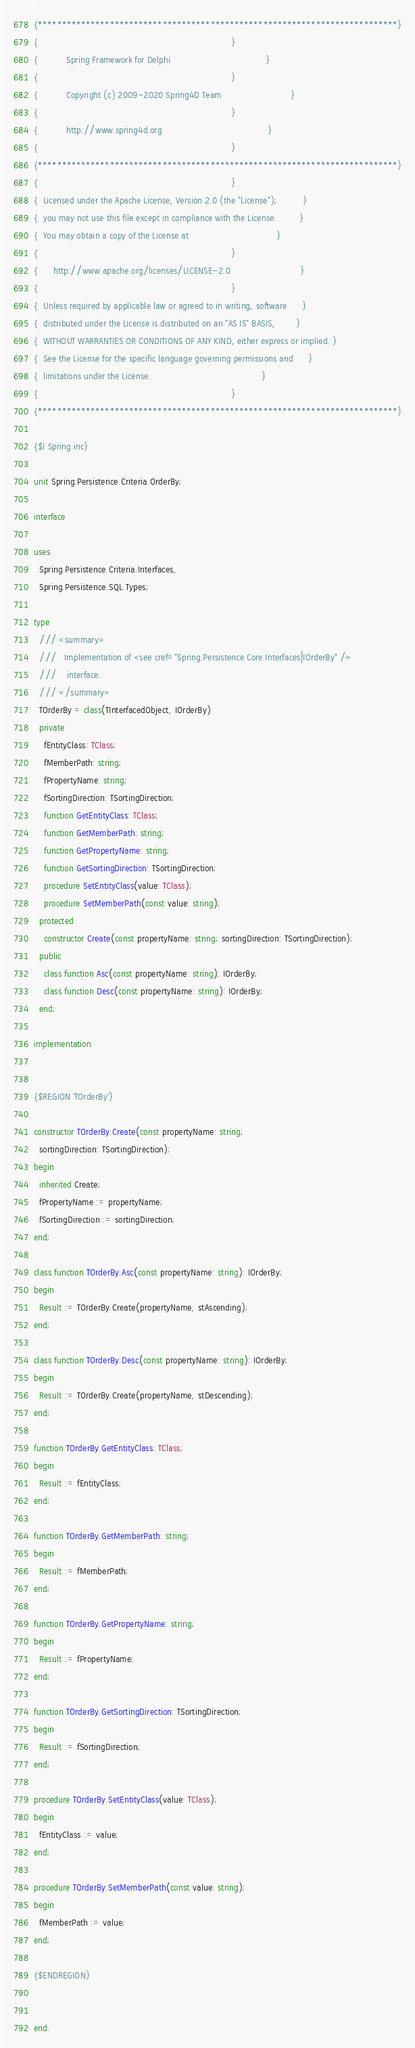Convert code to text. <code><loc_0><loc_0><loc_500><loc_500><_Pascal_>{***************************************************************************}
{                                                                           }
{           Spring Framework for Delphi                                     }
{                                                                           }
{           Copyright (c) 2009-2020 Spring4D Team                           }
{                                                                           }
{           http://www.spring4d.org                                         }
{                                                                           }
{***************************************************************************}
{                                                                           }
{  Licensed under the Apache License, Version 2.0 (the "License");          }
{  you may not use this file except in compliance with the License.         }
{  You may obtain a copy of the License at                                  }
{                                                                           }
{      http://www.apache.org/licenses/LICENSE-2.0                           }
{                                                                           }
{  Unless required by applicable law or agreed to in writing, software      }
{  distributed under the License is distributed on an "AS IS" BASIS,        }
{  WITHOUT WARRANTIES OR CONDITIONS OF ANY KIND, either express or implied. }
{  See the License for the specific language governing permissions and      }
{  limitations under the License.                                           }
{                                                                           }
{***************************************************************************}

{$I Spring.inc}

unit Spring.Persistence.Criteria.OrderBy;

interface

uses
  Spring.Persistence.Criteria.Interfaces,
  Spring.Persistence.SQL.Types;

type
  /// <summary>
  ///   Implementation of <see cref="Spring.Persistence.Core.Interfaces|IOrderBy" />
  ///    interface.
  /// </summary>
  TOrderBy = class(TInterfacedObject, IOrderBy)
  private
    fEntityClass: TClass;
    fMemberPath: string;
    fPropertyName: string;
    fSortingDirection: TSortingDirection;
    function GetEntityClass: TClass;
    function GetMemberPath: string;
    function GetPropertyName: string;
    function GetSortingDirection: TSortingDirection;
    procedure SetEntityClass(value: TClass);
    procedure SetMemberPath(const value: string);
  protected
    constructor Create(const propertyName: string; sortingDirection: TSortingDirection);
  public
    class function Asc(const propertyName: string): IOrderBy;
    class function Desc(const propertyName: string): IOrderBy;
  end;

implementation


{$REGION 'TOrderBy'}

constructor TOrderBy.Create(const propertyName: string;
  sortingDirection: TSortingDirection);
begin
  inherited Create;
  fPropertyName := propertyName;
  fSortingDirection := sortingDirection;
end;

class function TOrderBy.Asc(const propertyName: string): IOrderBy;
begin
  Result := TOrderBy.Create(propertyName, stAscending);
end;

class function TOrderBy.Desc(const propertyName: string): IOrderBy;
begin
  Result := TOrderBy.Create(propertyName, stDescending);
end;

function TOrderBy.GetEntityClass: TClass;
begin
  Result := fEntityClass;
end;

function TOrderBy.GetMemberPath: string;
begin
  Result := fMemberPath;
end;

function TOrderBy.GetPropertyName: string;
begin
  Result := fPropertyName;
end;

function TOrderBy.GetSortingDirection: TSortingDirection;
begin
  Result := fSortingDirection;
end;

procedure TOrderBy.SetEntityClass(value: TClass);
begin
  fEntityClass := value;
end;

procedure TOrderBy.SetMemberPath(const value: string);
begin
  fMemberPath := value;
end;

{$ENDREGION}


end.
</code> 